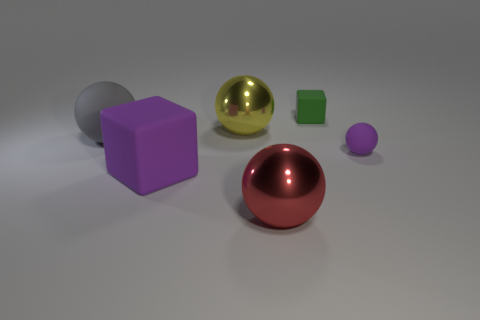Subtract 1 balls. How many balls are left? 3 Add 1 tiny green rubber objects. How many objects exist? 7 Subtract all cubes. How many objects are left? 4 Subtract 0 purple cylinders. How many objects are left? 6 Subtract all green metal cylinders. Subtract all tiny green blocks. How many objects are left? 5 Add 4 large rubber things. How many large rubber things are left? 6 Add 1 big gray metallic balls. How many big gray metallic balls exist? 1 